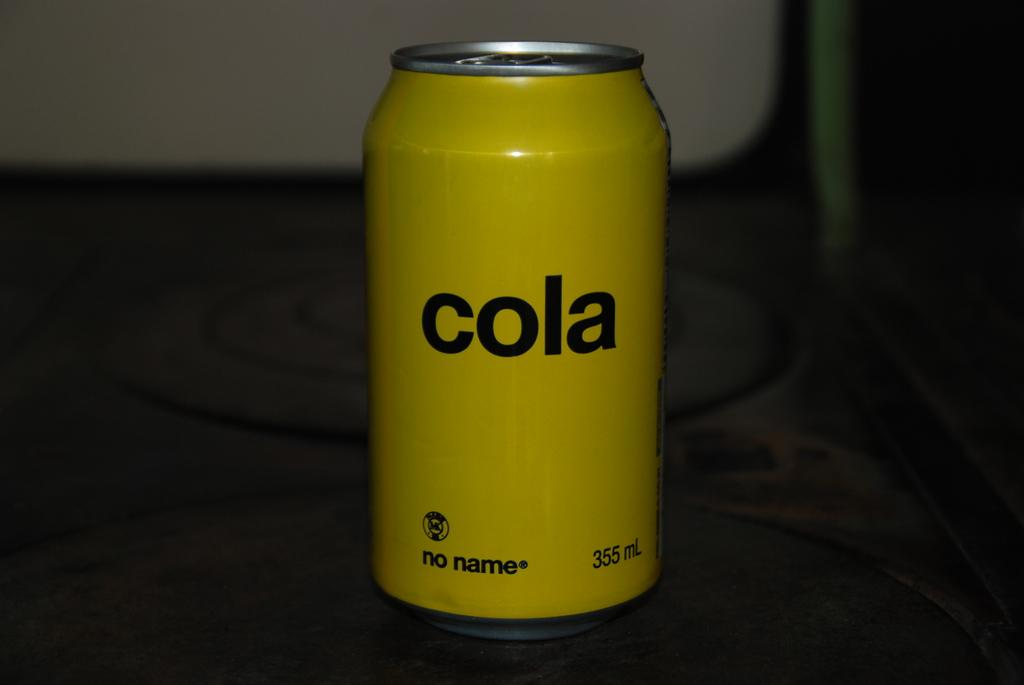<image>
Provide a brief description of the given image. A bright yellow can of no name brand cola sitting on a table. 